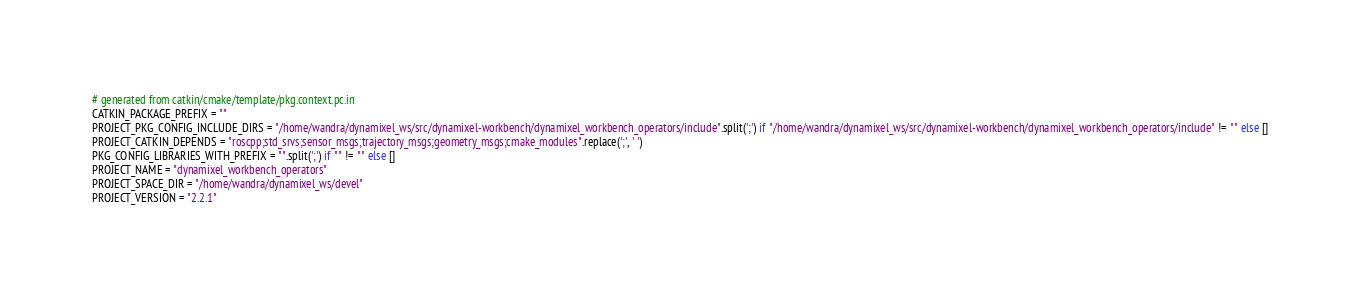<code> <loc_0><loc_0><loc_500><loc_500><_Python_># generated from catkin/cmake/template/pkg.context.pc.in
CATKIN_PACKAGE_PREFIX = ""
PROJECT_PKG_CONFIG_INCLUDE_DIRS = "/home/wandra/dynamixel_ws/src/dynamixel-workbench/dynamixel_workbench_operators/include".split(';') if "/home/wandra/dynamixel_ws/src/dynamixel-workbench/dynamixel_workbench_operators/include" != "" else []
PROJECT_CATKIN_DEPENDS = "roscpp;std_srvs;sensor_msgs;trajectory_msgs;geometry_msgs;cmake_modules".replace(';', ' ')
PKG_CONFIG_LIBRARIES_WITH_PREFIX = "".split(';') if "" != "" else []
PROJECT_NAME = "dynamixel_workbench_operators"
PROJECT_SPACE_DIR = "/home/wandra/dynamixel_ws/devel"
PROJECT_VERSION = "2.2.1"
</code> 